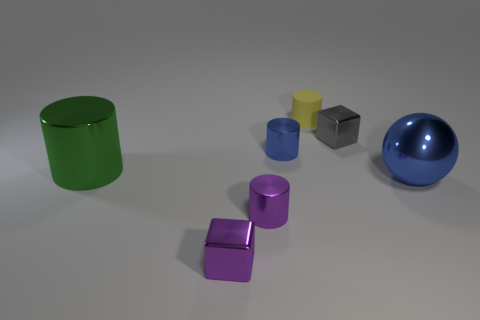Subtract all tiny purple metallic cylinders. How many cylinders are left? 3 Add 1 rubber cylinders. How many objects exist? 8 Subtract all blue cylinders. How many cylinders are left? 3 Subtract 4 cylinders. How many cylinders are left? 0 Subtract all purple spheres. Subtract all blue cylinders. How many spheres are left? 1 Subtract all gray metallic blocks. Subtract all big cylinders. How many objects are left? 5 Add 6 big green shiny cylinders. How many big green shiny cylinders are left? 7 Add 3 small gray things. How many small gray things exist? 4 Subtract 0 gray spheres. How many objects are left? 7 Subtract all cylinders. How many objects are left? 3 